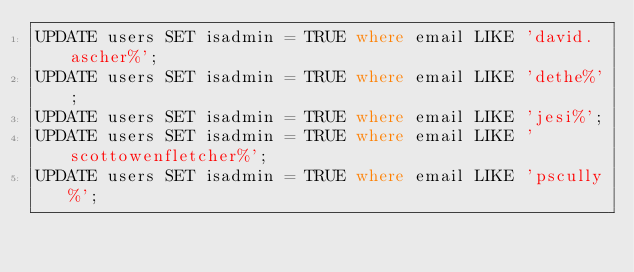Convert code to text. <code><loc_0><loc_0><loc_500><loc_500><_SQL_>UPDATE users SET isadmin = TRUE where email LIKE 'david.ascher%';
UPDATE users SET isadmin = TRUE where email LIKE 'dethe%';
UPDATE users SET isadmin = TRUE where email LIKE 'jesi%';
UPDATE users SET isadmin = TRUE where email LIKE 'scottowenfletcher%';
UPDATE users SET isadmin = TRUE where email LIKE 'pscully%';
</code> 